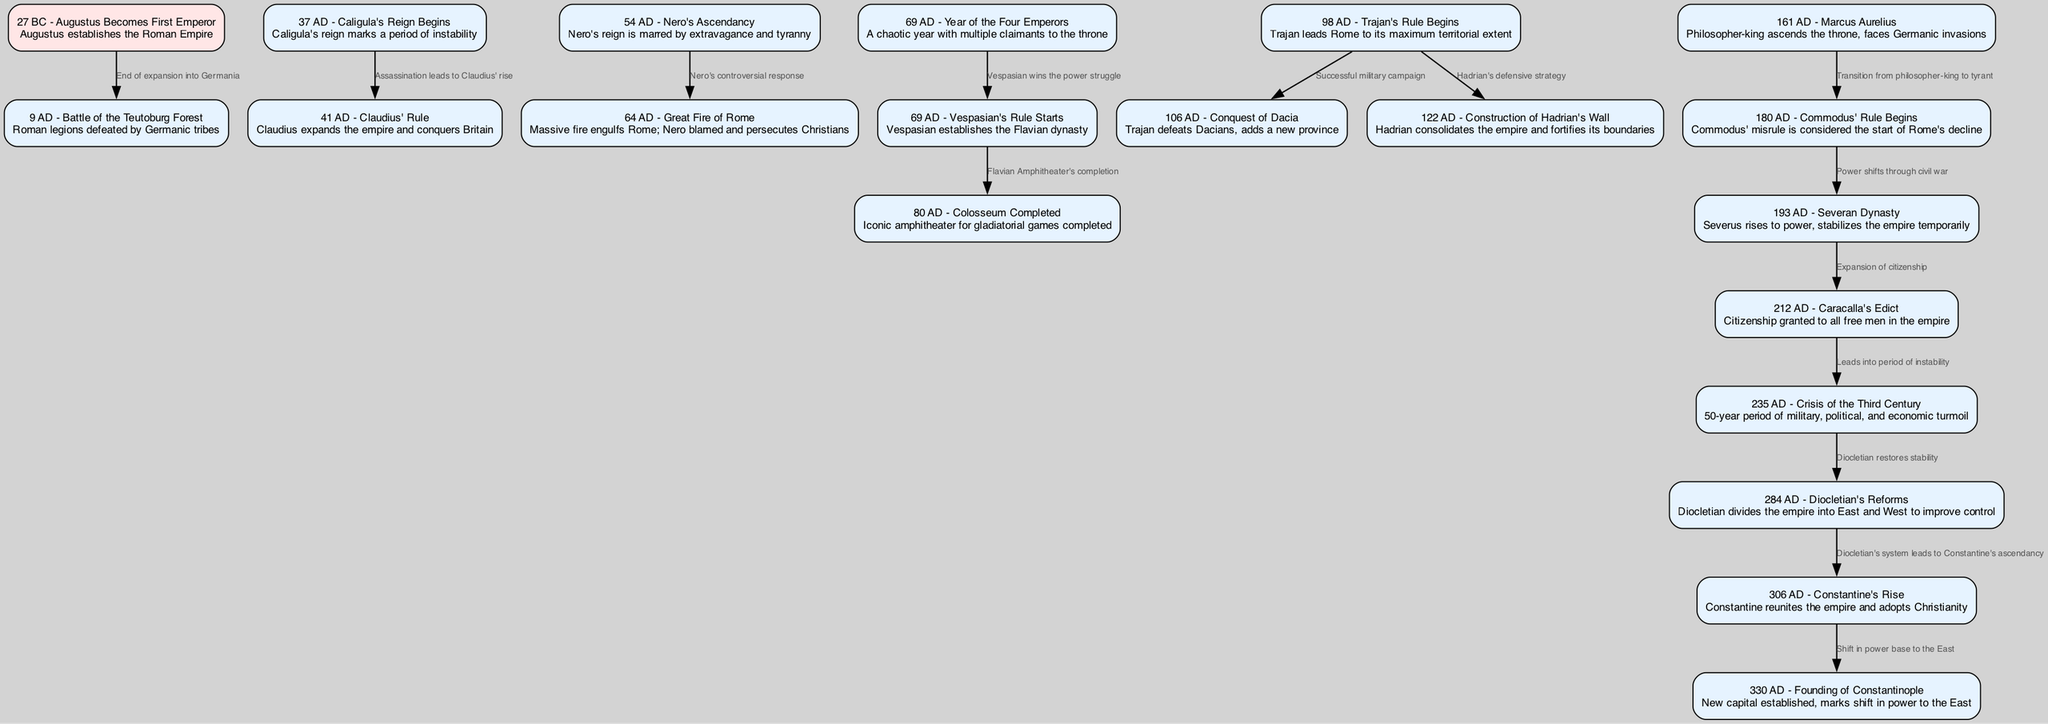What event marks the beginning of the Roman Empire? According to the diagram, Augustus becomes the first emperor in 27 BC, establishing the Roman Empire. This is the first node in the timeline and serves as the foundational event for the Empire's history.
Answer: 27 BC - Augustus Becomes First Emperor How many major battles are included in the diagram? There are two significant battles mentioned in the timeline: the Battle of the Teutoburg Forest in 9 AD and the event related to Trajan's successful military campaign leading to the Conquest of Dacia in 106 AD. Counting these events gives us the answer.
Answer: 2 What significant event occurred in 69 AD? The diagram indicates that in 69 AD, two key events occurred: the chaotic Year of the Four Emperors and the beginning of Vespasian's rule. Both events are linked through the same point in time.
Answer: Year of the Four Emperors and Vespasian's Rule What relationship exists between Nero and the Great Fire of Rome? The diagram shows an edge connecting Nero to the Great Fire of Rome in 64 AD, indicating that Nero's controversial response to the fire led to blame and the persecution of Christians, marking a significant political and social event.
Answer: Nero's controversial response Which emperor's rule is identified as the start of Rome's decline? The diagram shows that Commodus' rule, beginning in 180 AD, is marked as the start of Rome's decline, suggesting a transition from a stable governance to misrule.
Answer: Commodus' Rule Begins List three emperors who contributed to the expansion of the Roman Empire. From the diagram, the emperors recognized for their contributions to the expansion include Augustus (27 BC), Claudius (41 AD), and Trajan (98 AD), as their rule is associated with significant territorial growth.
Answer: Augustus, Claudius, Trajan What major crisis spanned from 235 AD to 284 AD? The diagram details that the period known as the Crisis of the Third Century lasted from 235 AD until the administrative reforms enacted by Diocletian in 284 AD, characterized by military, political, and economic turmoil.
Answer: Crisis of the Third Century How did Diocletian's reforms impact the structure of the Empire? Diocletian's reforms, as indicated in the diagram, involved dividing the empire into East and West to enhance control and stability. This restructuring is a crucial aspect of governance during his reign.
Answer: Divided the empire into East and West What led to the founding of Constantinople in 330 AD? The diagram states that the founding of Constantinople followed Constantine's rise and represented a shift in power base to the East, marking a significant political and strategic change in the Empire's history.
Answer: Shift in power base to the East 